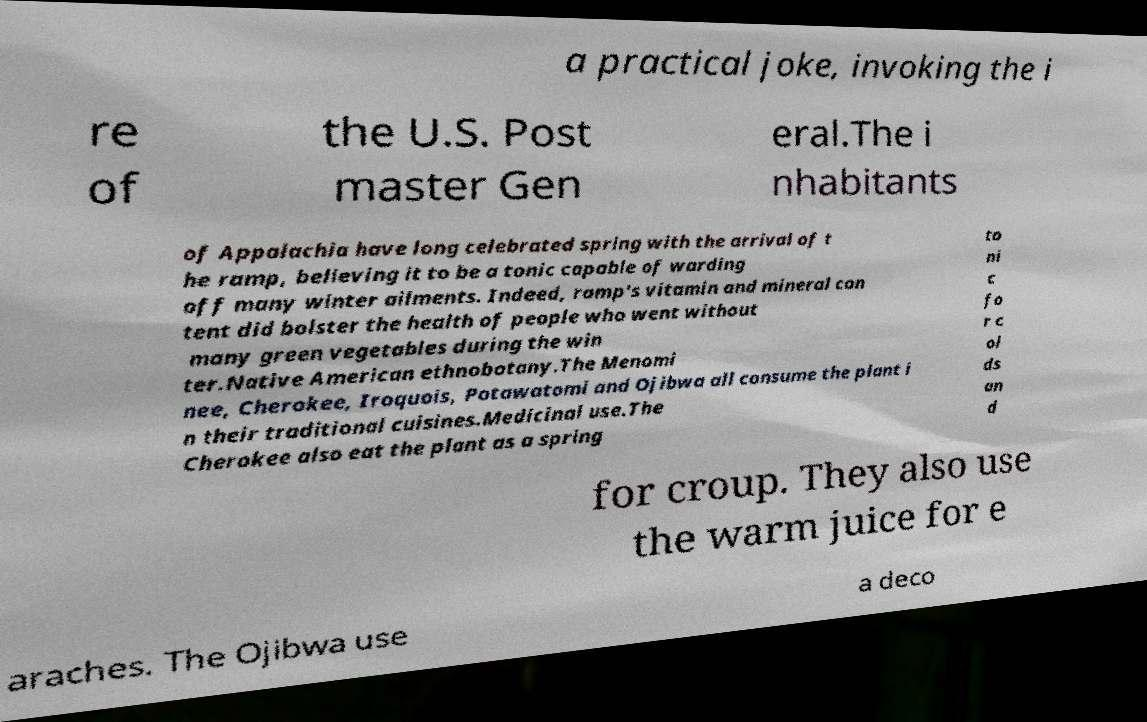Please read and relay the text visible in this image. What does it say? a practical joke, invoking the i re of the U.S. Post master Gen eral.The i nhabitants of Appalachia have long celebrated spring with the arrival of t he ramp, believing it to be a tonic capable of warding off many winter ailments. Indeed, ramp's vitamin and mineral con tent did bolster the health of people who went without many green vegetables during the win ter.Native American ethnobotany.The Menomi nee, Cherokee, Iroquois, Potawatomi and Ojibwa all consume the plant i n their traditional cuisines.Medicinal use.The Cherokee also eat the plant as a spring to ni c fo r c ol ds an d for croup. They also use the warm juice for e araches. The Ojibwa use a deco 